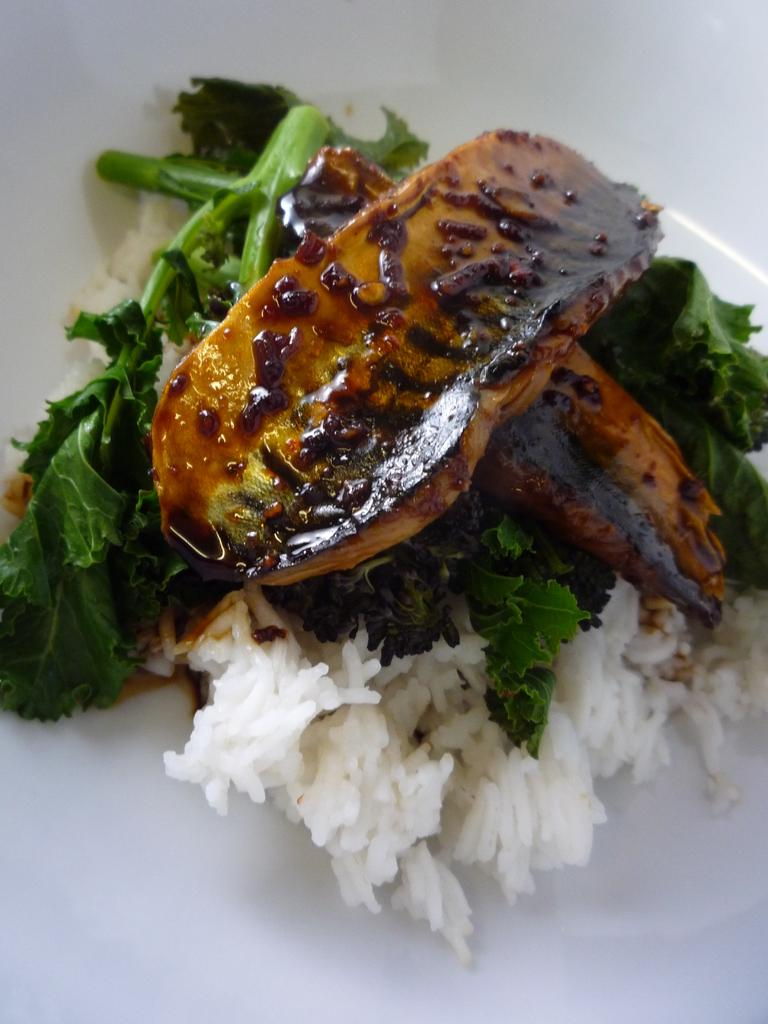What is present on the plate in the image? There are food items on a plate in the image. What type of coal is used to fuel the fire in the image? There is no coal or fire present in the image; it features a plate with food items. 